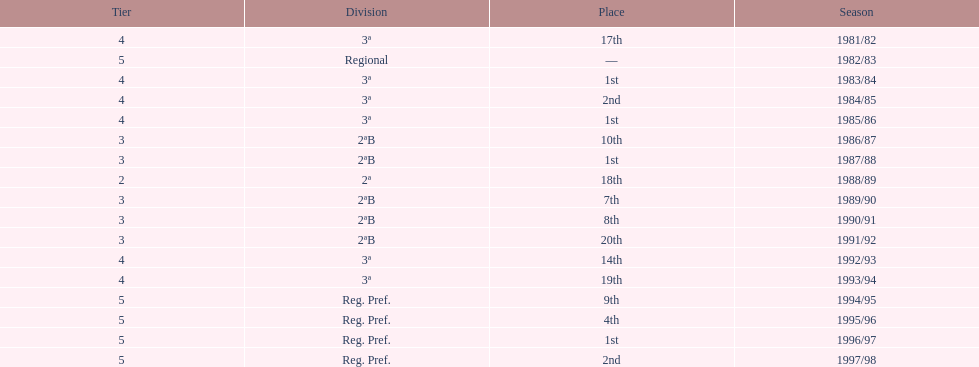In which year did the team have its worst season? 1991/92. 